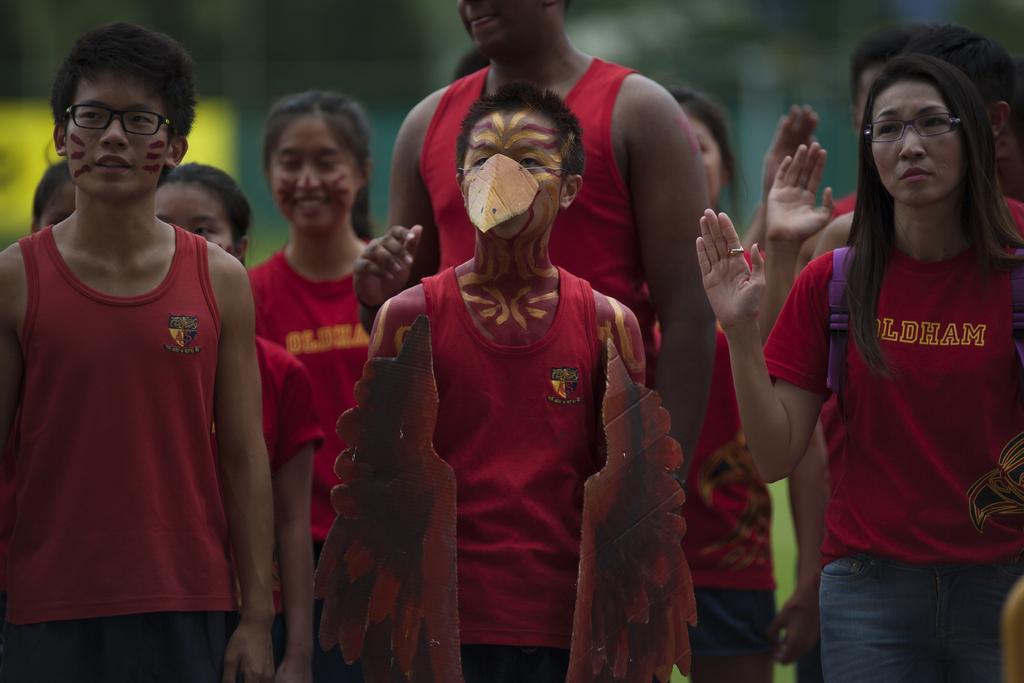Could you give a brief overview of what you see in this image? Here we can see few persons were both men and woman are standing and few raised their hands and in the front we can see a man having made parts of a bird on him. 